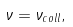<formula> <loc_0><loc_0><loc_500><loc_500>\nu = \nu _ { c o l l } ,</formula> 